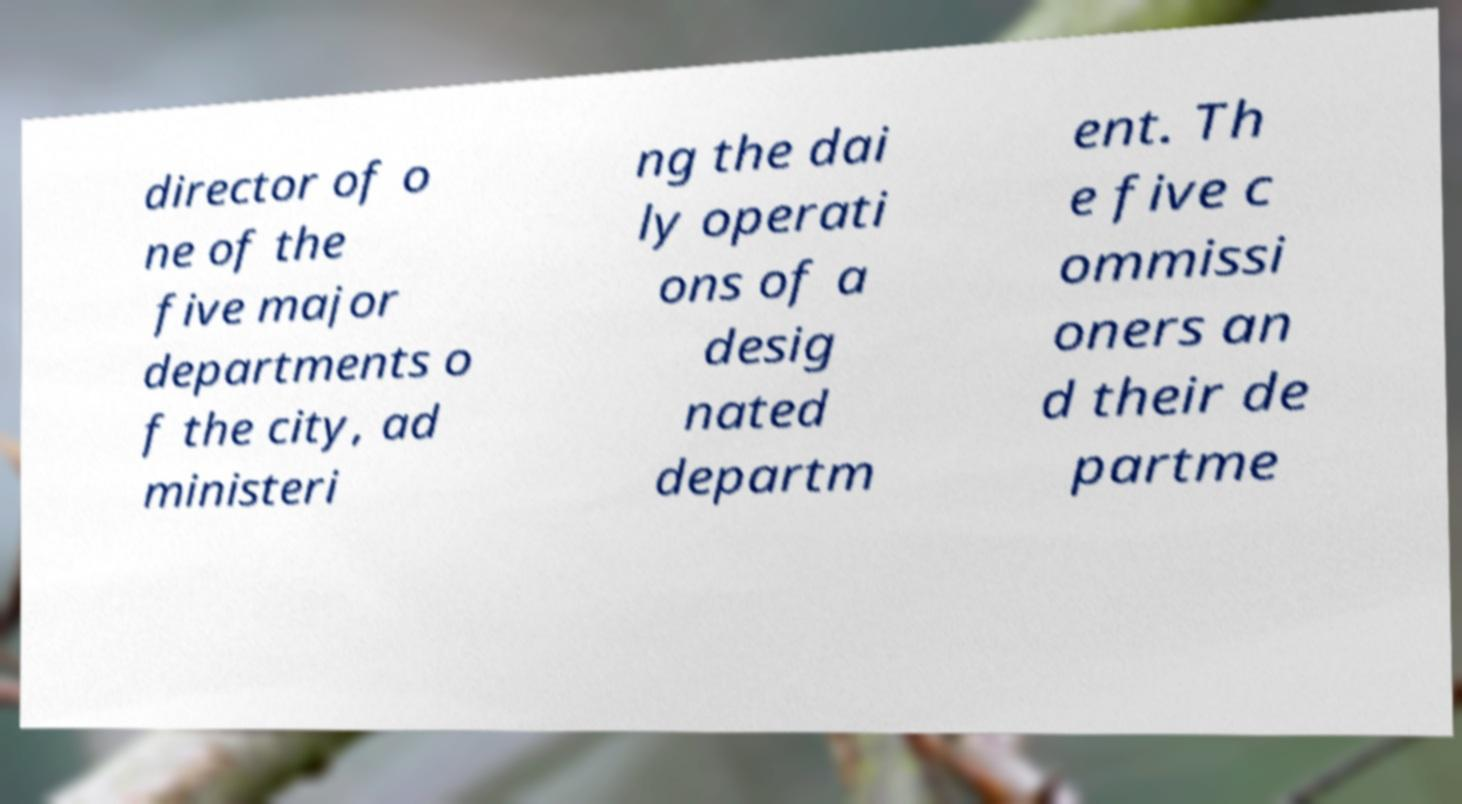I need the written content from this picture converted into text. Can you do that? director of o ne of the five major departments o f the city, ad ministeri ng the dai ly operati ons of a desig nated departm ent. Th e five c ommissi oners an d their de partme 